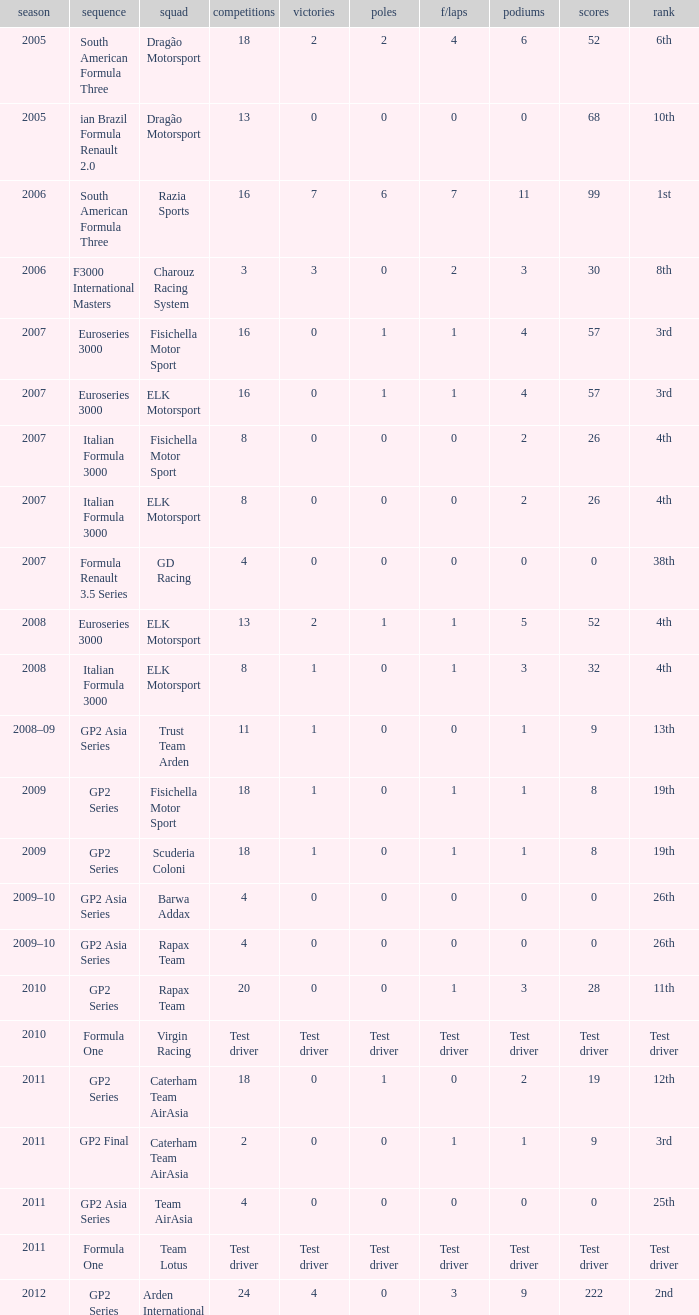What were the points in the year when his Podiums were 5? 52.0. 